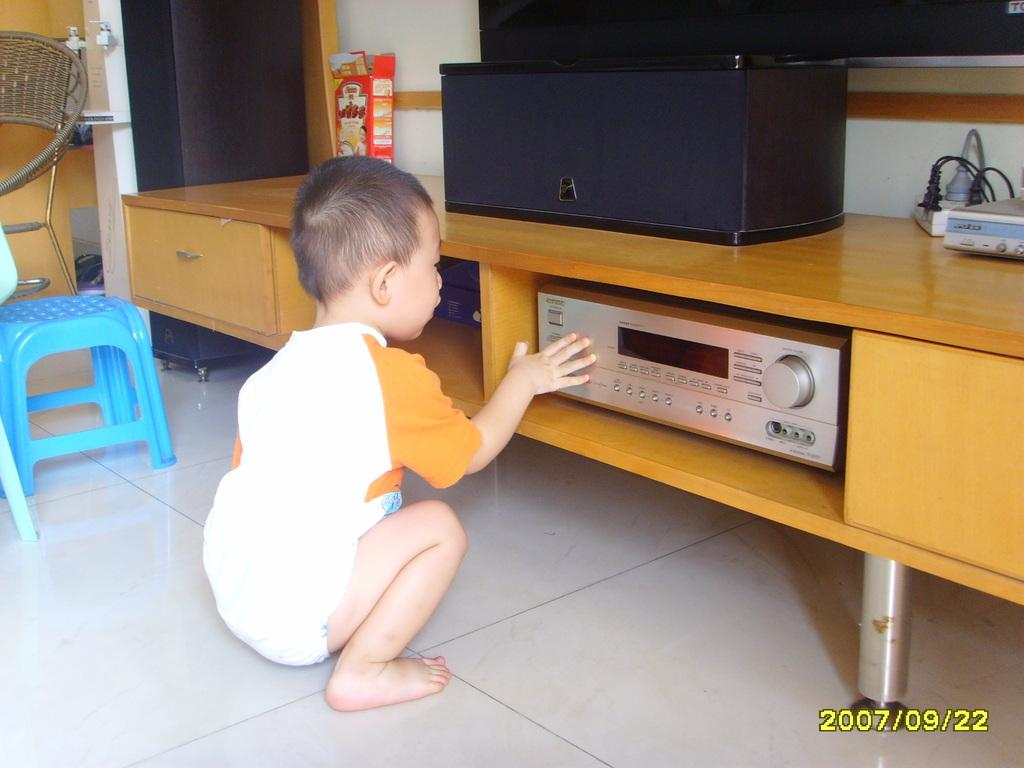What is the main subject of the image? The main subject of the image is a kid. What is the kid doing in the image? The kid is touching a music system. Where is the music system located? The music system is on a table. What is beside the kid in the image? There is a blue stool beside the kid. What type of ticket is the kid holding in the image? There is no ticket present in the image; the kid is touching a music system. Is the kid reading a book while sitting on the blue stool? There is no book or reading activity depicted in the image; the kid is touching a music system, and there is a blue stool beside them. 